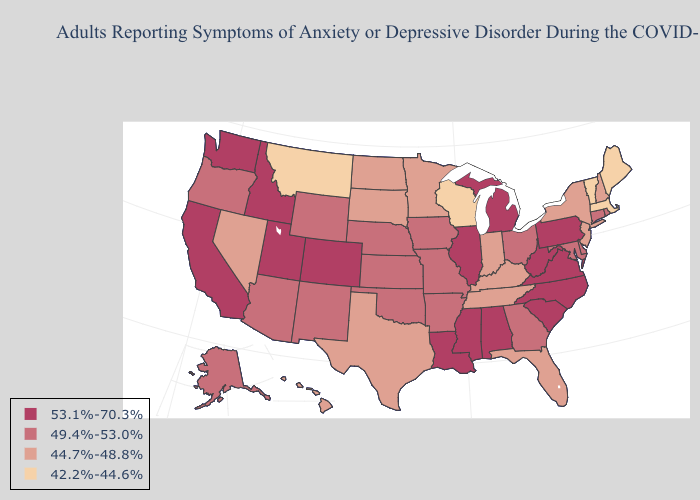Does the first symbol in the legend represent the smallest category?
Give a very brief answer. No. Does Georgia have a higher value than Tennessee?
Concise answer only. Yes. Does Tennessee have a lower value than Hawaii?
Give a very brief answer. No. What is the lowest value in the South?
Concise answer only. 44.7%-48.8%. Among the states that border California , which have the lowest value?
Answer briefly. Nevada. Does California have the highest value in the USA?
Keep it brief. Yes. Which states have the lowest value in the South?
Short answer required. Florida, Kentucky, Tennessee, Texas. Name the states that have a value in the range 53.1%-70.3%?
Quick response, please. Alabama, California, Colorado, Idaho, Illinois, Louisiana, Michigan, Mississippi, North Carolina, Pennsylvania, South Carolina, Utah, Virginia, Washington, West Virginia. What is the value of Colorado?
Quick response, please. 53.1%-70.3%. Among the states that border Connecticut , which have the highest value?
Short answer required. Rhode Island. Does Oklahoma have the lowest value in the South?
Answer briefly. No. What is the lowest value in the South?
Keep it brief. 44.7%-48.8%. Which states have the lowest value in the USA?
Answer briefly. Maine, Massachusetts, Montana, Vermont, Wisconsin. Which states have the lowest value in the MidWest?
Keep it brief. Wisconsin. 